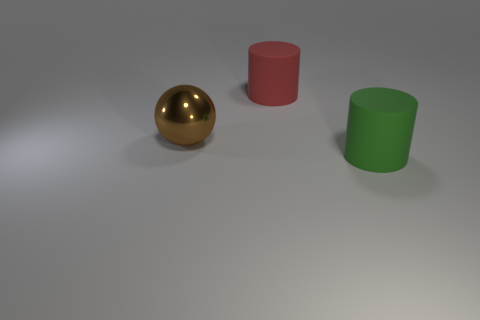Does the thing that is behind the large ball have the same material as the object in front of the brown shiny object?
Provide a succinct answer. Yes. There is a large object that is behind the brown metal ball; what shape is it?
Your answer should be compact. Cylinder. How many objects are small purple metallic cubes or large objects right of the big shiny sphere?
Your answer should be compact. 2. Does the big brown sphere have the same material as the big green thing?
Make the answer very short. No. Is the number of big things to the right of the big green matte object the same as the number of cylinders in front of the brown thing?
Ensure brevity in your answer.  No. There is a red matte thing; how many big objects are to the right of it?
Your response must be concise. 1. What number of things are either tiny brown metallic blocks or large green objects?
Keep it short and to the point. 1. What number of yellow metal cubes are the same size as the red matte object?
Your response must be concise. 0. What shape is the big red matte thing behind the big matte cylinder on the right side of the red cylinder?
Give a very brief answer. Cylinder. Is the number of large red rubber cylinders less than the number of gray cylinders?
Give a very brief answer. No. 